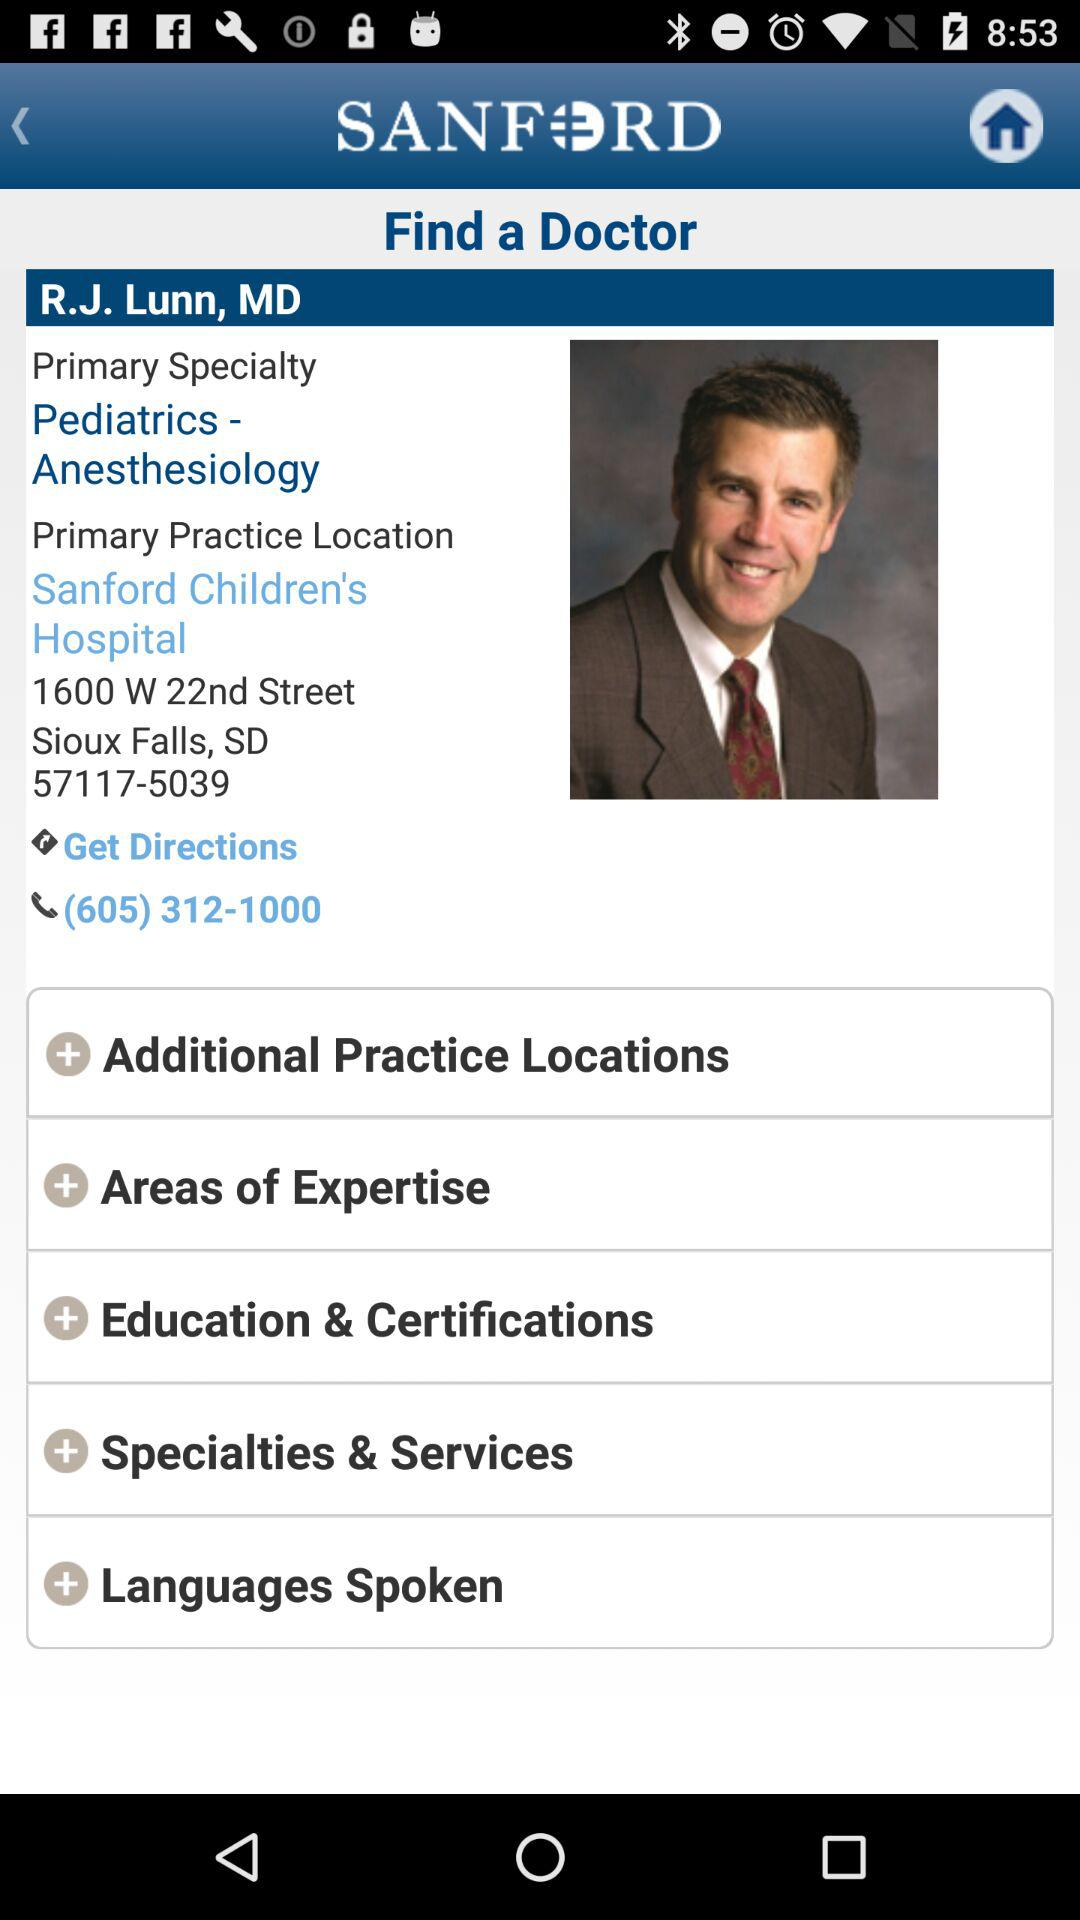What is the doctor's primary specialty? The doctor's primary specialty is "Pediatrics - Anesthesiology". 